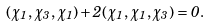<formula> <loc_0><loc_0><loc_500><loc_500>( \chi _ { 1 } , \chi _ { 3 } , \chi _ { 1 } ) + 2 ( \chi _ { 1 } , \chi _ { 1 } , \chi _ { 3 } ) = 0 .</formula> 